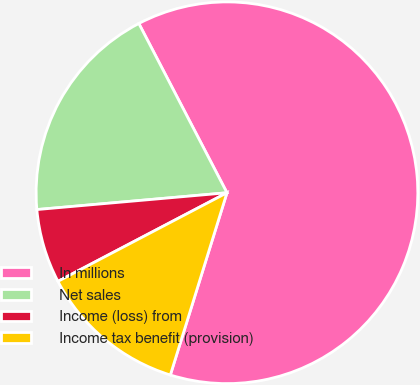Convert chart to OTSL. <chart><loc_0><loc_0><loc_500><loc_500><pie_chart><fcel>In millions<fcel>Net sales<fcel>Income (loss) from<fcel>Income tax benefit (provision)<nl><fcel>62.43%<fcel>18.76%<fcel>6.28%<fcel>12.52%<nl></chart> 